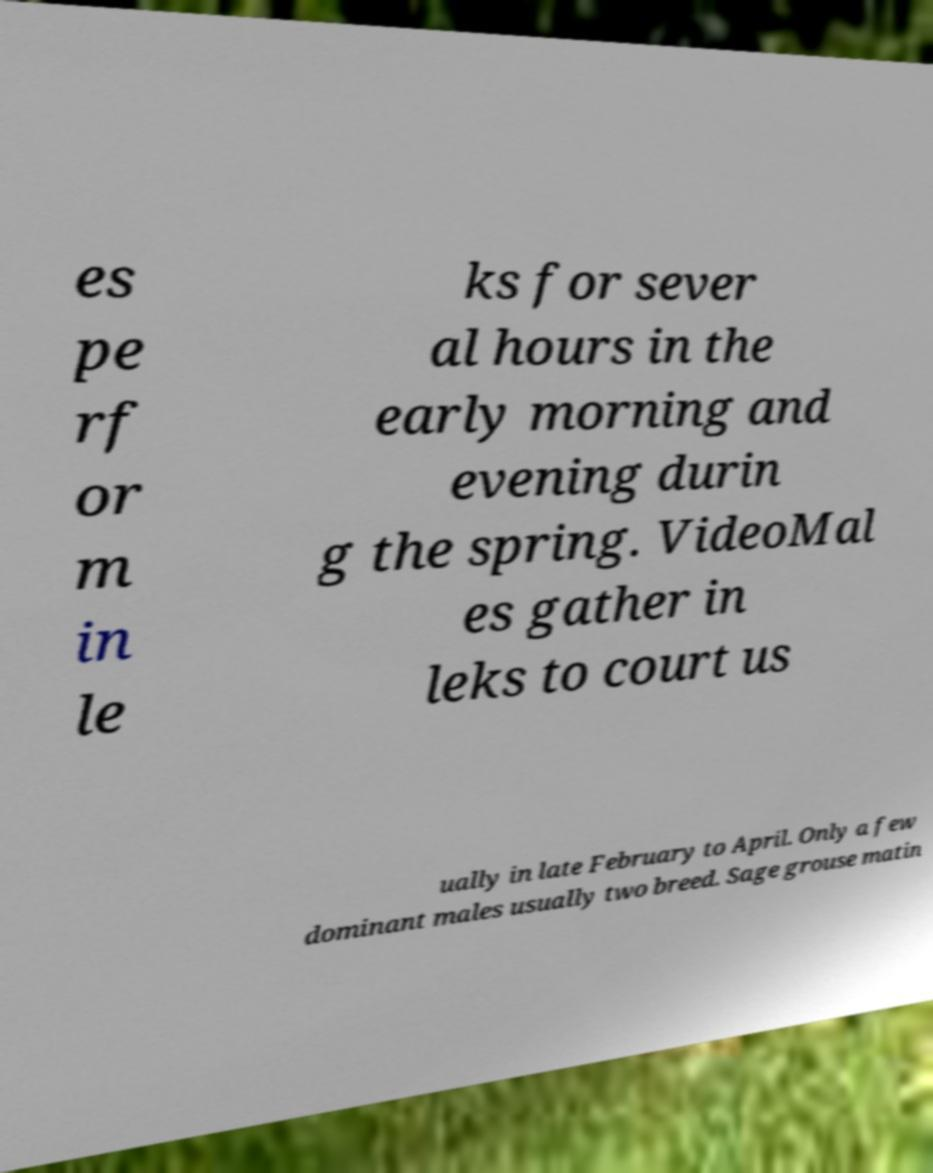Please identify and transcribe the text found in this image. es pe rf or m in le ks for sever al hours in the early morning and evening durin g the spring. VideoMal es gather in leks to court us ually in late February to April. Only a few dominant males usually two breed. Sage grouse matin 